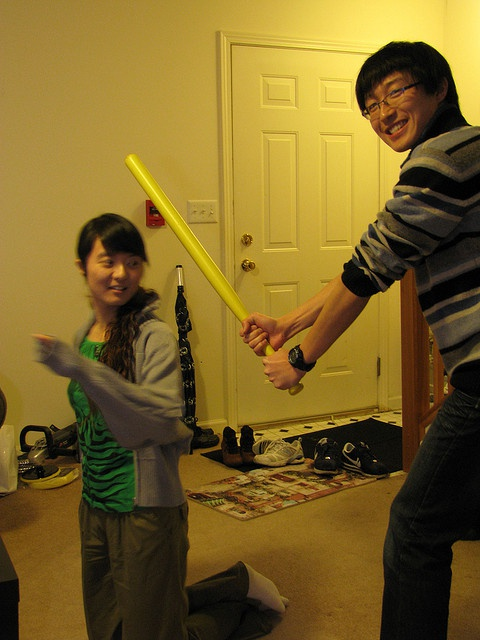Describe the objects in this image and their specific colors. I can see people in olive, black, maroon, and brown tones, people in olive, black, and maroon tones, baseball bat in olive and gold tones, and umbrella in olive and black tones in this image. 